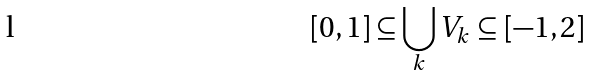Convert formula to latex. <formula><loc_0><loc_0><loc_500><loc_500>[ 0 , 1 ] \subseteq \bigcup _ { k } V _ { k } \subseteq [ - 1 , 2 ]</formula> 